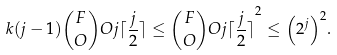Convert formula to latex. <formula><loc_0><loc_0><loc_500><loc_500>k ( j - 1 ) \binom { F } { O } O { j } { \lceil \frac { j } { 2 } \rceil } \leq { \binom { F } { O } O { j } { \lceil \frac { j } { 2 } \rceil } } ^ { 2 } \leq { \left ( 2 ^ { j } \right ) } ^ { 2 } .</formula> 